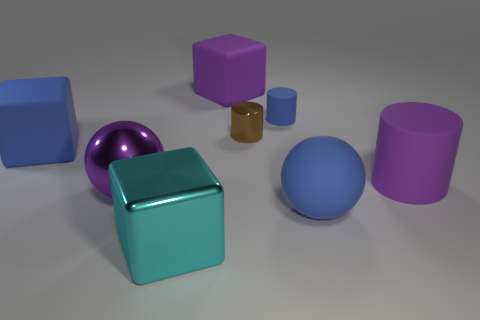Add 1 large purple metallic things. How many objects exist? 9 Subtract all tiny metal cylinders. How many cylinders are left? 2 Subtract 1 cubes. How many cubes are left? 2 Subtract all blocks. How many objects are left? 5 Subtract all green cylinders. Subtract all purple cubes. How many cylinders are left? 3 Add 6 brown things. How many brown things exist? 7 Subtract 0 cyan balls. How many objects are left? 8 Subtract all small brown cylinders. Subtract all cyan metal things. How many objects are left? 6 Add 3 metal balls. How many metal balls are left? 4 